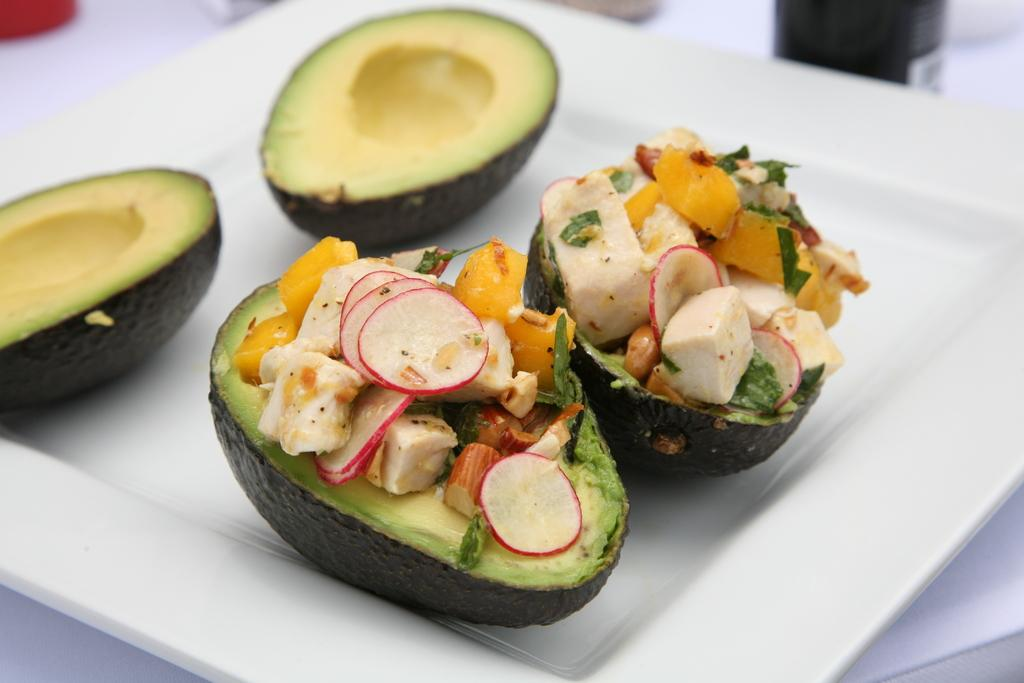What type of fruit can be seen in the image? There are Peach fruit pieces in the image. What is on top of the Peach fruit pieces? There are different ingredients on the Peach fruit pieces. What color is the plate that holds the Peach fruit pieces? The plate is white in color. How many girls are sitting on the bear in the image? There are no girls or bears present in the image; it features Peach fruit pieces with different ingredients on top. 